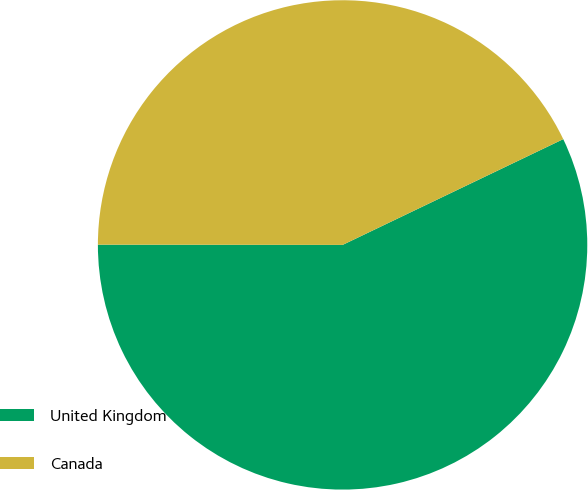Convert chart. <chart><loc_0><loc_0><loc_500><loc_500><pie_chart><fcel>United Kingdom<fcel>Canada<nl><fcel>57.13%<fcel>42.87%<nl></chart> 